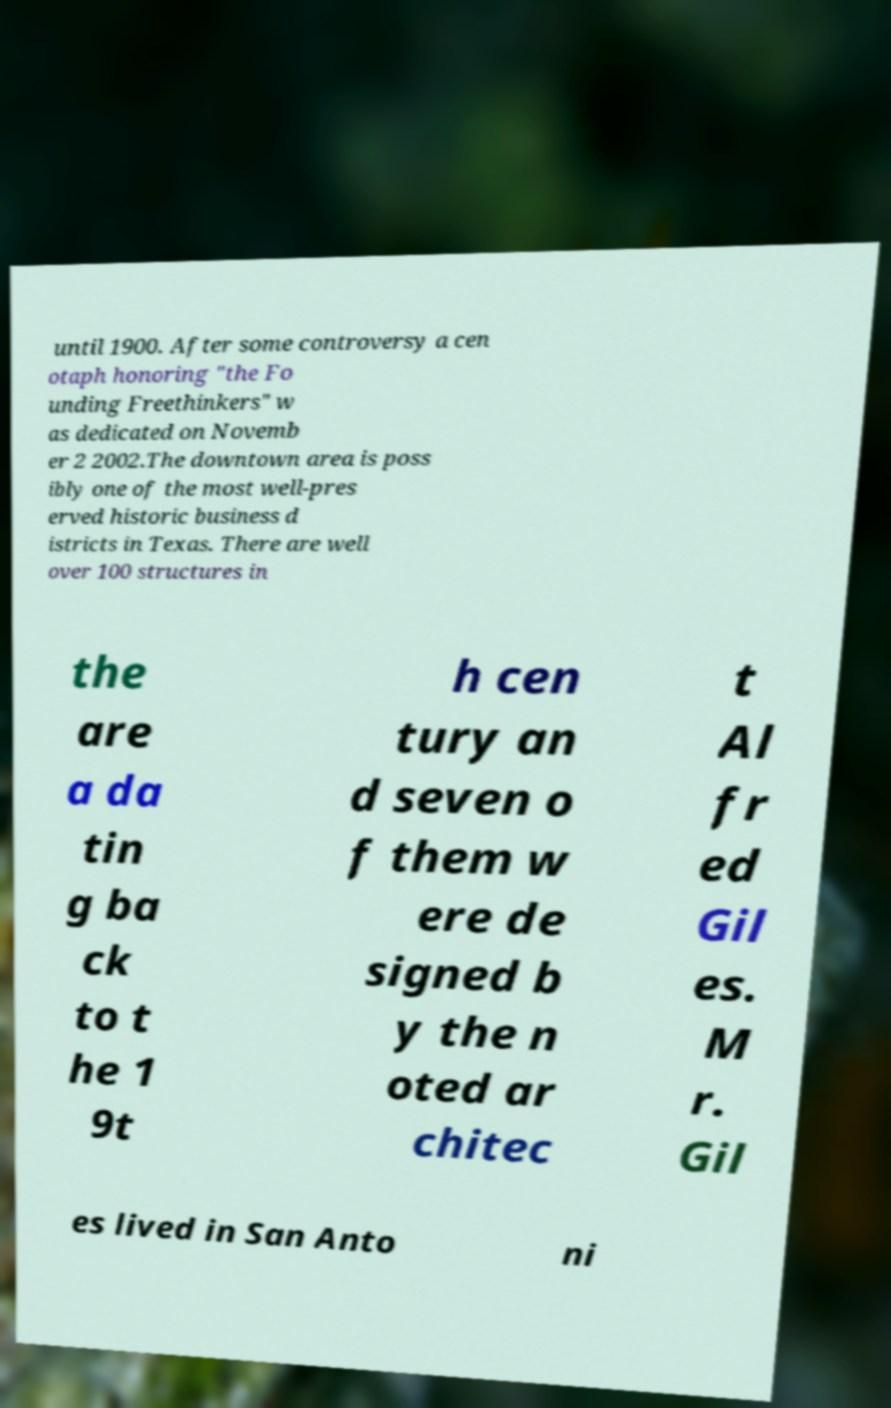For documentation purposes, I need the text within this image transcribed. Could you provide that? until 1900. After some controversy a cen otaph honoring "the Fo unding Freethinkers" w as dedicated on Novemb er 2 2002.The downtown area is poss ibly one of the most well-pres erved historic business d istricts in Texas. There are well over 100 structures in the are a da tin g ba ck to t he 1 9t h cen tury an d seven o f them w ere de signed b y the n oted ar chitec t Al fr ed Gil es. M r. Gil es lived in San Anto ni 